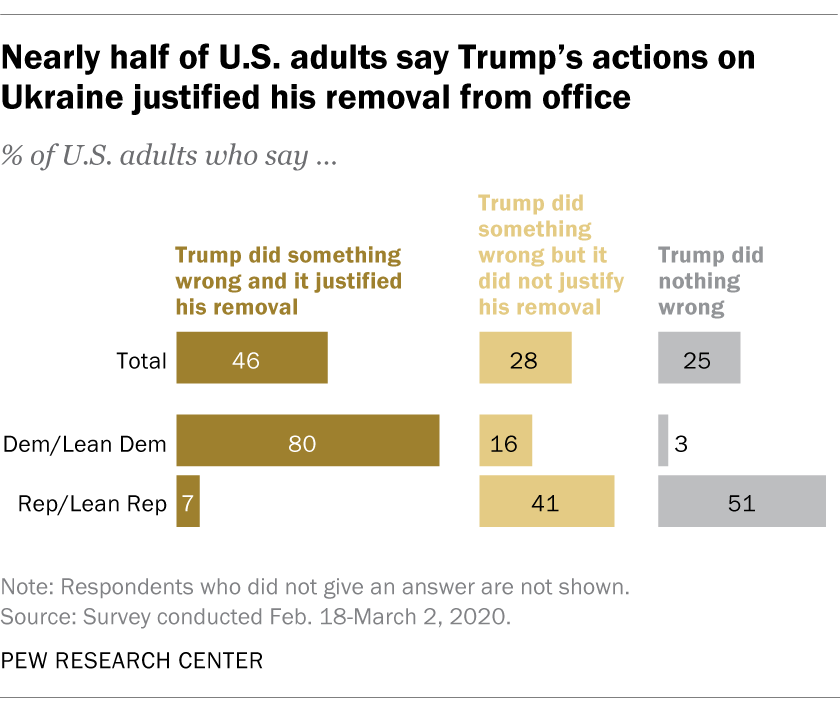Specify some key components in this picture. According to a recent survey, 46% of Americans believe that President Trump has done something wrong. A recent survey indicates that a significant portion of Democrats and Republicans believe that President Trump has done something wrong, with a radio between those who think he did something wrong and those who think he did nothing wrong at 3.338194444... 